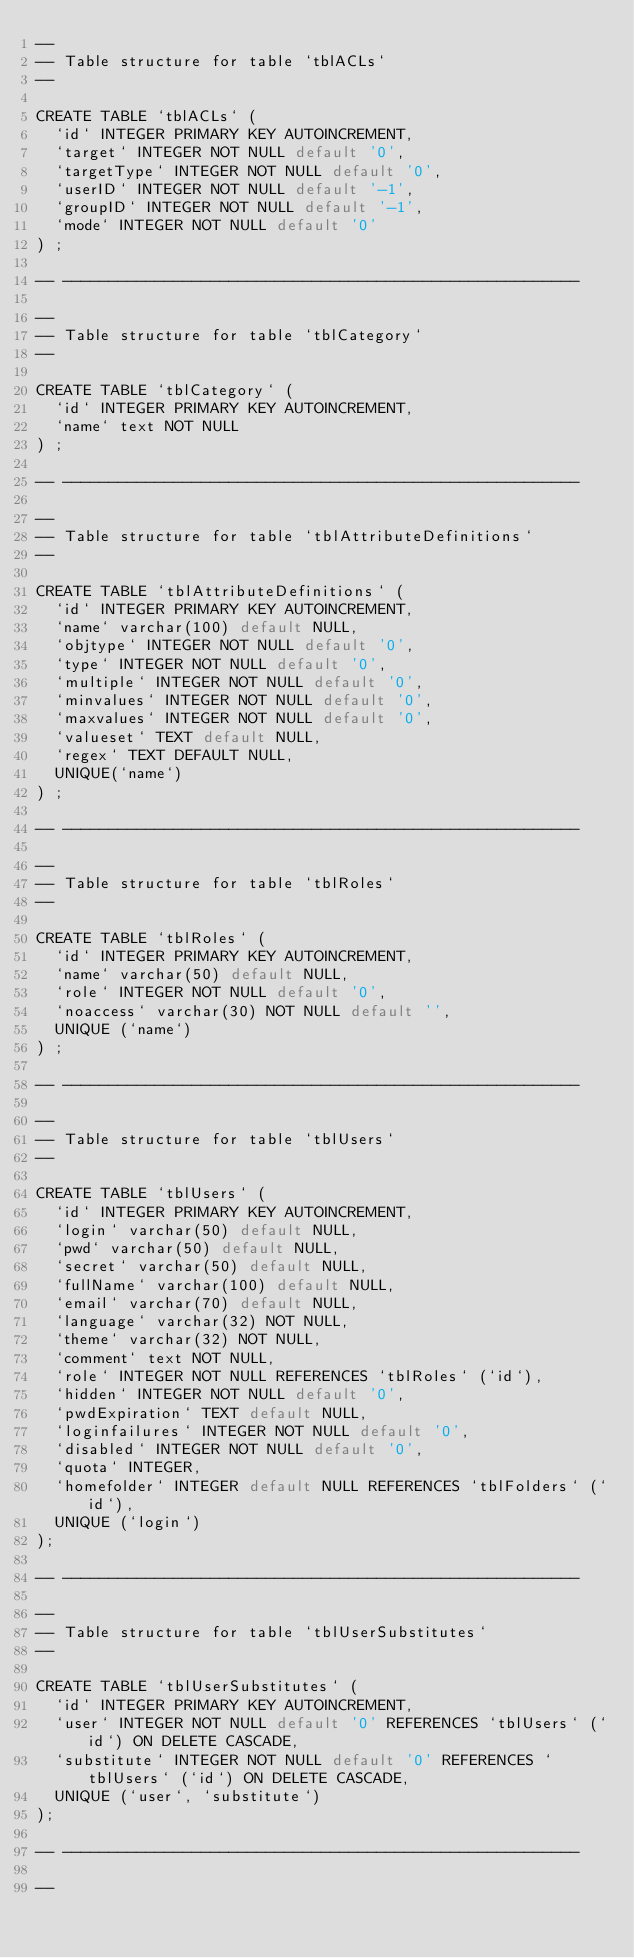<code> <loc_0><loc_0><loc_500><loc_500><_SQL_>--
-- Table structure for table `tblACLs`
--

CREATE TABLE `tblACLs` (
  `id` INTEGER PRIMARY KEY AUTOINCREMENT,
  `target` INTEGER NOT NULL default '0',
  `targetType` INTEGER NOT NULL default '0',
  `userID` INTEGER NOT NULL default '-1',
  `groupID` INTEGER NOT NULL default '-1',
  `mode` INTEGER NOT NULL default '0'
) ;

-- --------------------------------------------------------

--
-- Table structure for table `tblCategory`
--

CREATE TABLE `tblCategory` (
  `id` INTEGER PRIMARY KEY AUTOINCREMENT,
  `name` text NOT NULL
) ;

-- --------------------------------------------------------

--
-- Table structure for table `tblAttributeDefinitions`
--

CREATE TABLE `tblAttributeDefinitions` (
  `id` INTEGER PRIMARY KEY AUTOINCREMENT,
  `name` varchar(100) default NULL,
  `objtype` INTEGER NOT NULL default '0',
  `type` INTEGER NOT NULL default '0',
  `multiple` INTEGER NOT NULL default '0',
  `minvalues` INTEGER NOT NULL default '0',
  `maxvalues` INTEGER NOT NULL default '0',
  `valueset` TEXT default NULL,
  `regex` TEXT DEFAULT NULL,
  UNIQUE(`name`)
) ;

-- --------------------------------------------------------

--
-- Table structure for table `tblRoles`
--

CREATE TABLE `tblRoles` (
  `id` INTEGER PRIMARY KEY AUTOINCREMENT,
  `name` varchar(50) default NULL,
  `role` INTEGER NOT NULL default '0',
  `noaccess` varchar(30) NOT NULL default '',
  UNIQUE (`name`)
) ;

-- --------------------------------------------------------

--
-- Table structure for table `tblUsers`
--

CREATE TABLE `tblUsers` (
  `id` INTEGER PRIMARY KEY AUTOINCREMENT,
  `login` varchar(50) default NULL,
  `pwd` varchar(50) default NULL,
  `secret` varchar(50) default NULL,
  `fullName` varchar(100) default NULL,
  `email` varchar(70) default NULL,
  `language` varchar(32) NOT NULL,
  `theme` varchar(32) NOT NULL,
  `comment` text NOT NULL,
  `role` INTEGER NOT NULL REFERENCES `tblRoles` (`id`),
  `hidden` INTEGER NOT NULL default '0',
  `pwdExpiration` TEXT default NULL,
  `loginfailures` INTEGER NOT NULL default '0',
  `disabled` INTEGER NOT NULL default '0',
  `quota` INTEGER,
  `homefolder` INTEGER default NULL REFERENCES `tblFolders` (`id`),
  UNIQUE (`login`)
);

-- --------------------------------------------------------

--
-- Table structure for table `tblUserSubstitutes`
--

CREATE TABLE `tblUserSubstitutes` (
  `id` INTEGER PRIMARY KEY AUTOINCREMENT,
  `user` INTEGER NOT NULL default '0' REFERENCES `tblUsers` (`id`) ON DELETE CASCADE,
  `substitute` INTEGER NOT NULL default '0' REFERENCES `tblUsers` (`id`) ON DELETE CASCADE,
  UNIQUE (`user`, `substitute`)
);

-- --------------------------------------------------------

--</code> 